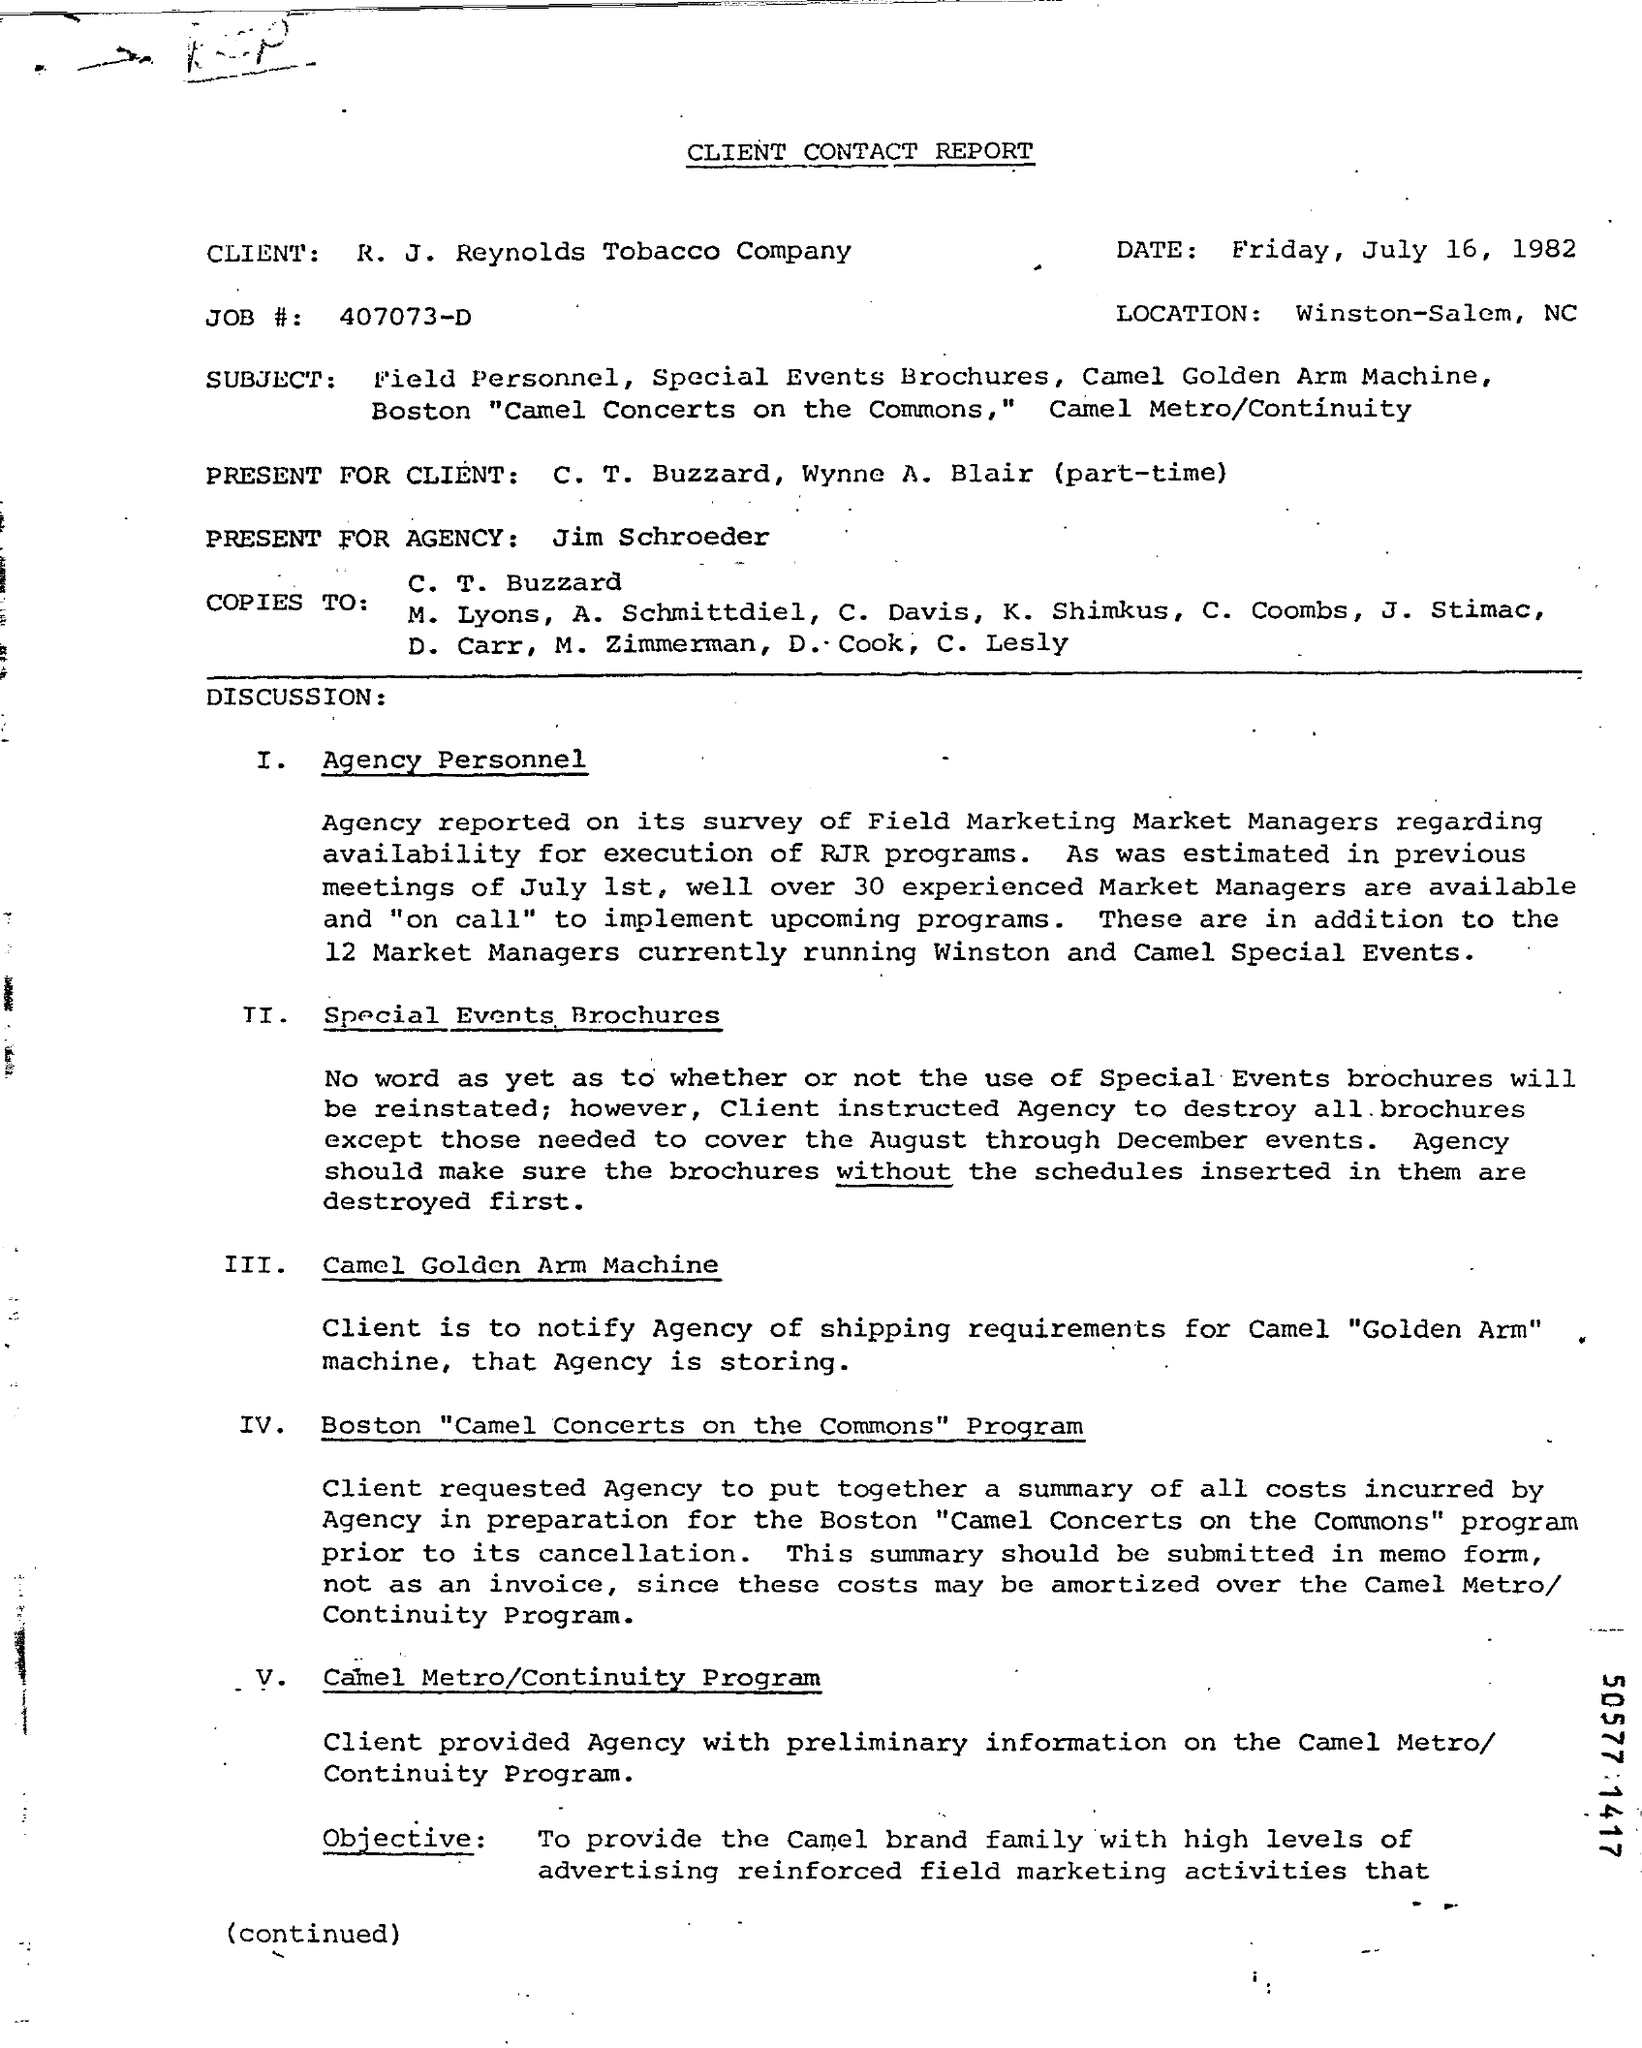What is the job number?
Your answer should be very brief. 407073-D. How many market managers are currently running Winston and camel special events?
Offer a terse response. 12. 